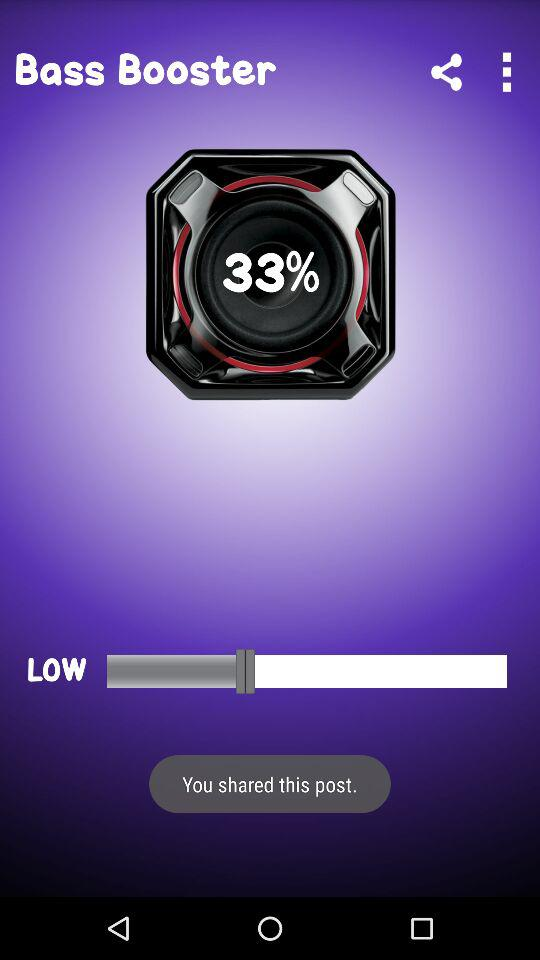What is the percentage of the volume level that is currently being used?
Answer the question using a single word or phrase. 33% 